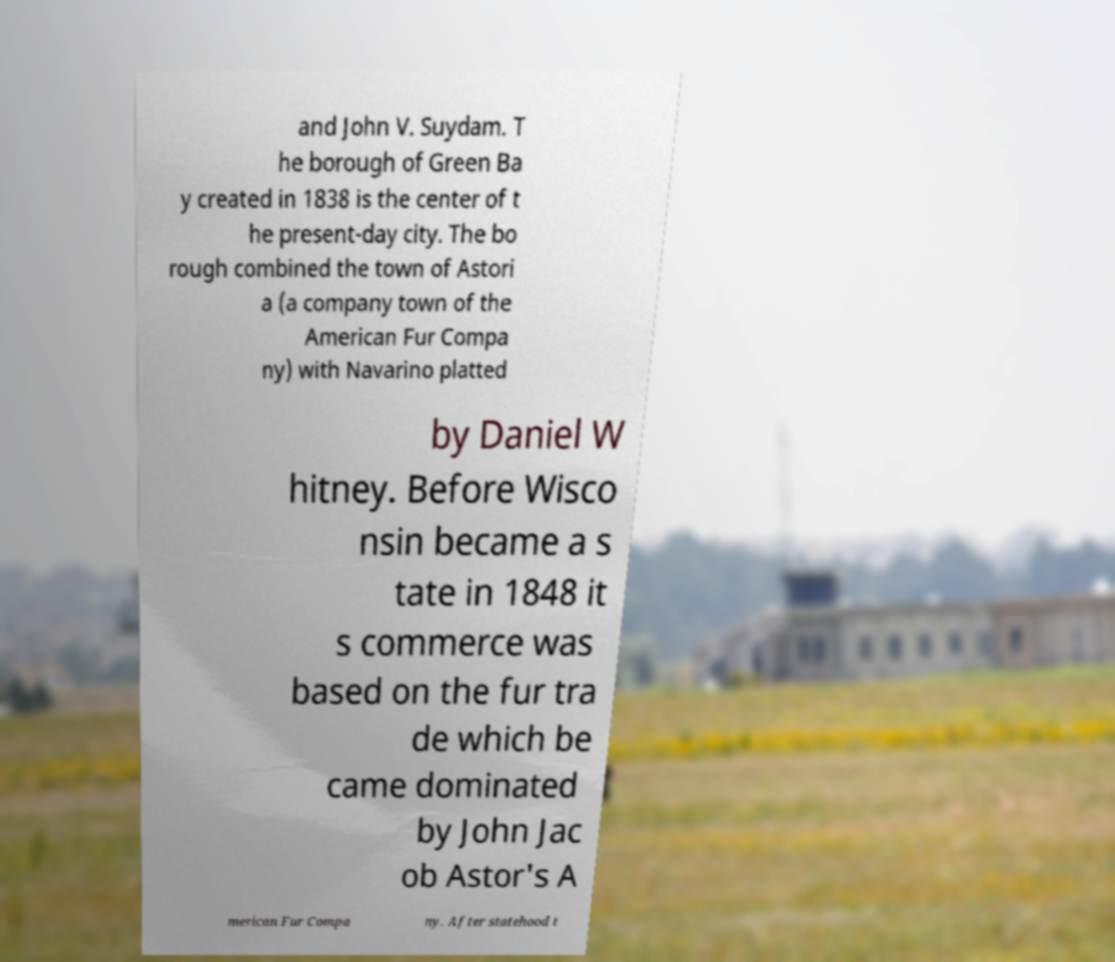Could you assist in decoding the text presented in this image and type it out clearly? and John V. Suydam. T he borough of Green Ba y created in 1838 is the center of t he present-day city. The bo rough combined the town of Astori a (a company town of the American Fur Compa ny) with Navarino platted by Daniel W hitney. Before Wisco nsin became a s tate in 1848 it s commerce was based on the fur tra de which be came dominated by John Jac ob Astor's A merican Fur Compa ny. After statehood t 